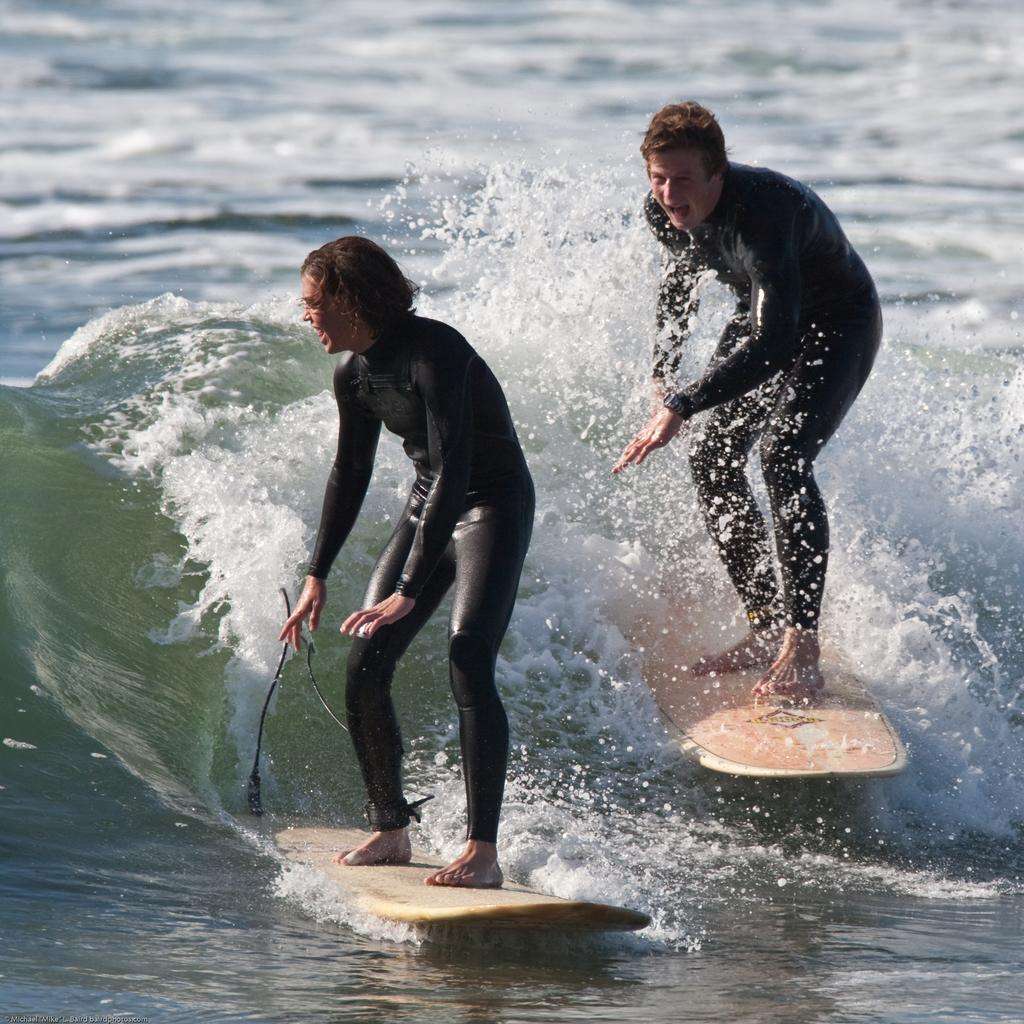How many people are in the image? There are persons in the image. What are the persons doing in the image? The persons are surfing. Where is the surfing taking place? The surfing is taking place on the sea. What type of match is being played in the image? There is no match being played in the image; the persons are surfing on the sea. How many legs does the surfboard have in the image? The surfboard does not have legs; it is a single object used for surfing. 